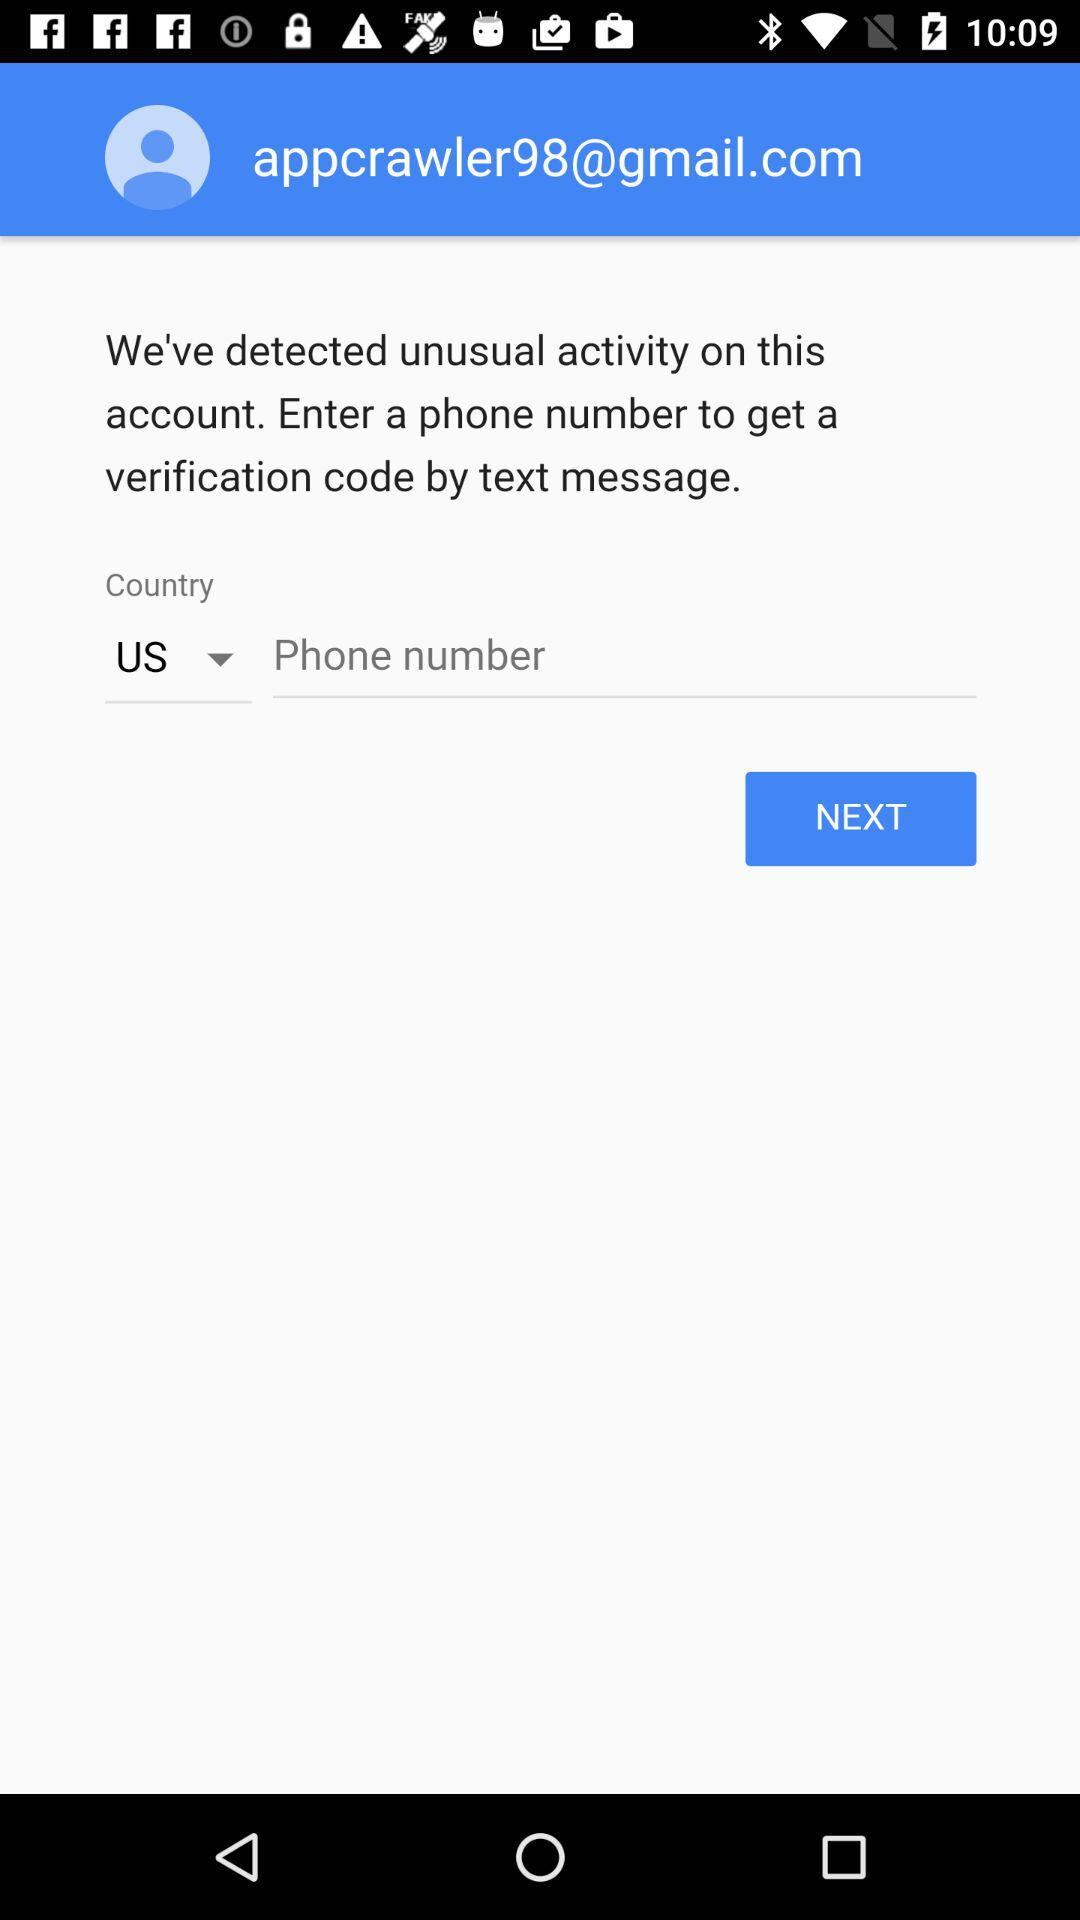What is the email address? The email address is appcrawler98@gmail.com. 